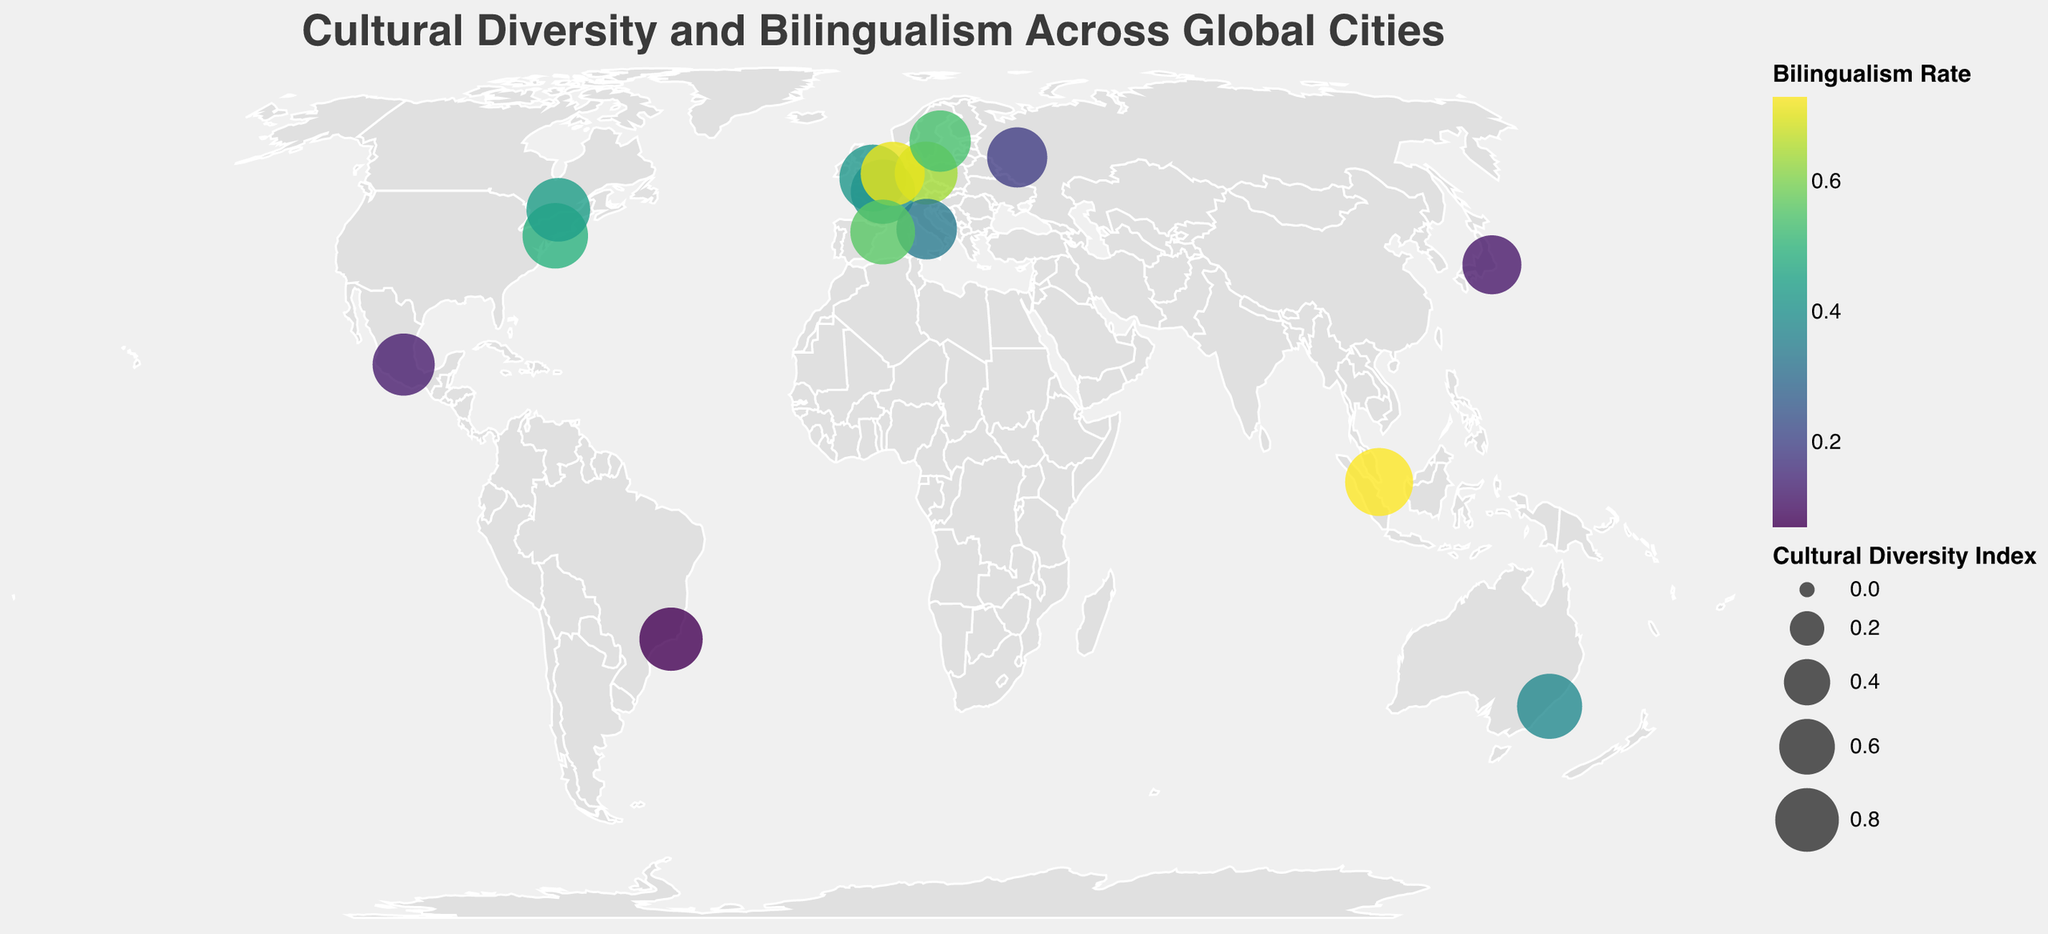What does the title of the figure indicate? The title of the figure is "Cultural Diversity and Bilingualism Across Global Cities," which suggests that the plot shows the relationship between cultural diversity and bilingualism across different cities around the world.
Answer: Cultural diversity and bilingualism in global cities How many cities are represented in the plot? The plot represents data points for each city, and by counting these points or checking the data provided, there are 15 cities in total.
Answer: 15 Which city has the highest Cultural Diversity Index? By looking at the legend that shows circle sizes, the largest circle, representing the highest Cultural Diversity Index, is over Singapore.
Answer: Singapore Which city has the lowest Bilingualism Rate? By referring to the color legend and identifying the lightest colored circle, which corresponds to the lowest bilingualism rate, the city is Rio de Janeiro.
Answer: Rio de Janeiro Which cities have both a high Cultural Diversity Index and a high Bilingualism Rate? By observing the circle sizes and colors, the cities with large and dark-colored circles are Singapore, Amsterdam, and Berlin, indicating both high cultural diversity and high bilingualism rates.
Answer: Singapore, Amsterdam, Berlin What is the Cultural Diversity Index of London? By reviewing the tooltip information when hovering over the circle representing London, the Cultural Diversity Index is shown as 0.89.
Answer: 0.89 Which city out of Tokyo, Mexico City, and Moscow has the highest Bilingualism Rate? By comparing the colors of these cities' respective circles, which correspond to the Bilingualism Rate, Tokyo has the highest Bilingualism Rate among the three.
Answer: Tokyo Is there a discernible relationship between the Cultural Diversity Index and Bilingualism Rate? By analyzing the plot, cities with higher Cultural Diversity Index tend to have darker colors, indicating higher Bilingualism Rates, suggesting a positive correlation.
Answer: Positive correlation What is the difference in Bilingualism Rate between Barcelona and Rome? The Bilingualism Rate for Barcelona is 0.56, and for Rome, it is 0.34. The difference is 0.56 - 0.34 = 0.22.
Answer: 0.22 Are there more cities with a Cultural Diversity Index above or below 0.80? By counting the number of circles with sizes indicating a Cultural Diversity Index above and below 0.80, there are 7 cities above and 8 cities below.
Answer: Below 